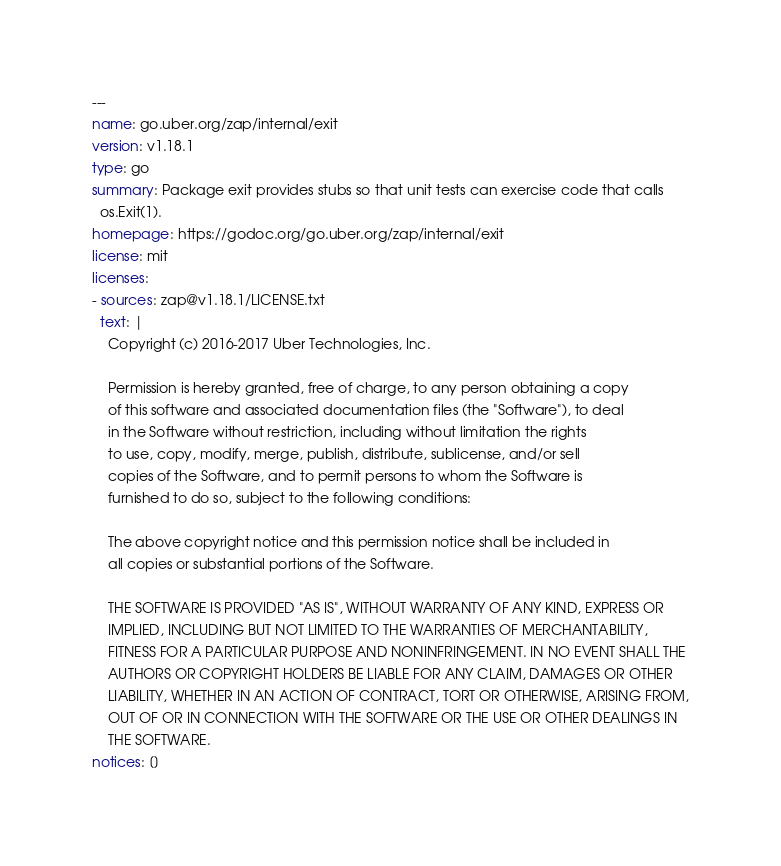Convert code to text. <code><loc_0><loc_0><loc_500><loc_500><_YAML_>---
name: go.uber.org/zap/internal/exit
version: v1.18.1
type: go
summary: Package exit provides stubs so that unit tests can exercise code that calls
  os.Exit(1).
homepage: https://godoc.org/go.uber.org/zap/internal/exit
license: mit
licenses:
- sources: zap@v1.18.1/LICENSE.txt
  text: |
    Copyright (c) 2016-2017 Uber Technologies, Inc.

    Permission is hereby granted, free of charge, to any person obtaining a copy
    of this software and associated documentation files (the "Software"), to deal
    in the Software without restriction, including without limitation the rights
    to use, copy, modify, merge, publish, distribute, sublicense, and/or sell
    copies of the Software, and to permit persons to whom the Software is
    furnished to do so, subject to the following conditions:

    The above copyright notice and this permission notice shall be included in
    all copies or substantial portions of the Software.

    THE SOFTWARE IS PROVIDED "AS IS", WITHOUT WARRANTY OF ANY KIND, EXPRESS OR
    IMPLIED, INCLUDING BUT NOT LIMITED TO THE WARRANTIES OF MERCHANTABILITY,
    FITNESS FOR A PARTICULAR PURPOSE AND NONINFRINGEMENT. IN NO EVENT SHALL THE
    AUTHORS OR COPYRIGHT HOLDERS BE LIABLE FOR ANY CLAIM, DAMAGES OR OTHER
    LIABILITY, WHETHER IN AN ACTION OF CONTRACT, TORT OR OTHERWISE, ARISING FROM,
    OUT OF OR IN CONNECTION WITH THE SOFTWARE OR THE USE OR OTHER DEALINGS IN
    THE SOFTWARE.
notices: []
</code> 